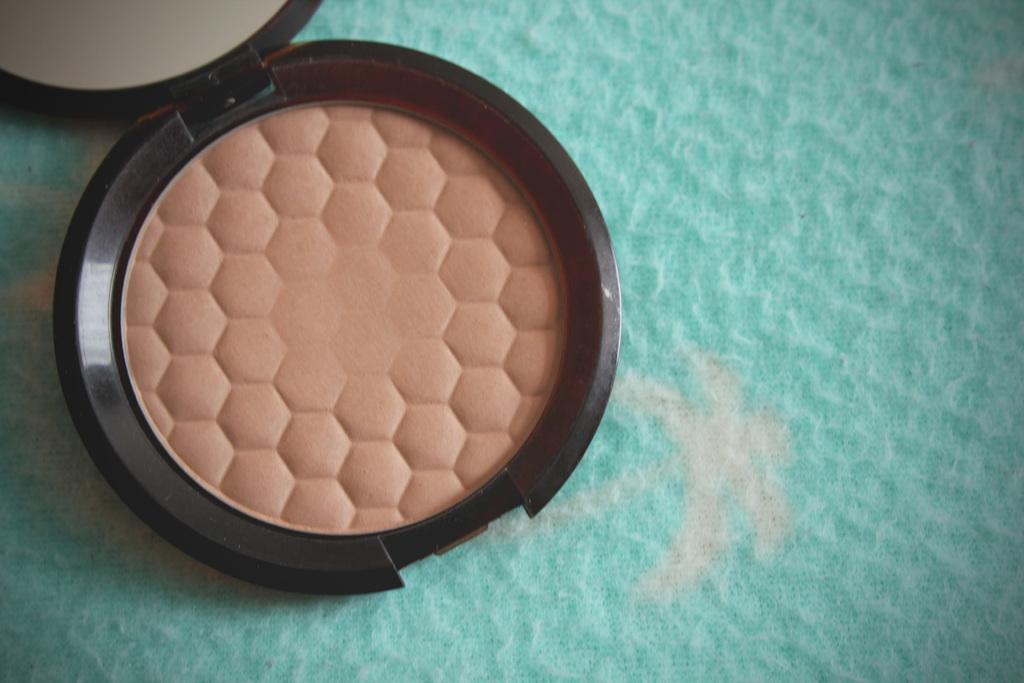What cosmetic item is visible in the image? There is a face powder in the image. What is used for self-grooming and reflection in the image? There is a mirror in the image. Where is the mirror located in the image? The mirror is located at the left side top corner of the image. What color is the surface on which the mirror is placed? The mirror is placed on a green surface. What type of muscle can be seen flexing in the image? There are no muscles visible in the image; it features a face powder and a mirror. What taste sensation is associated with the face powder in the image? Face powder is not meant to be tasted, so there is no taste sensation associated with it in the image. 